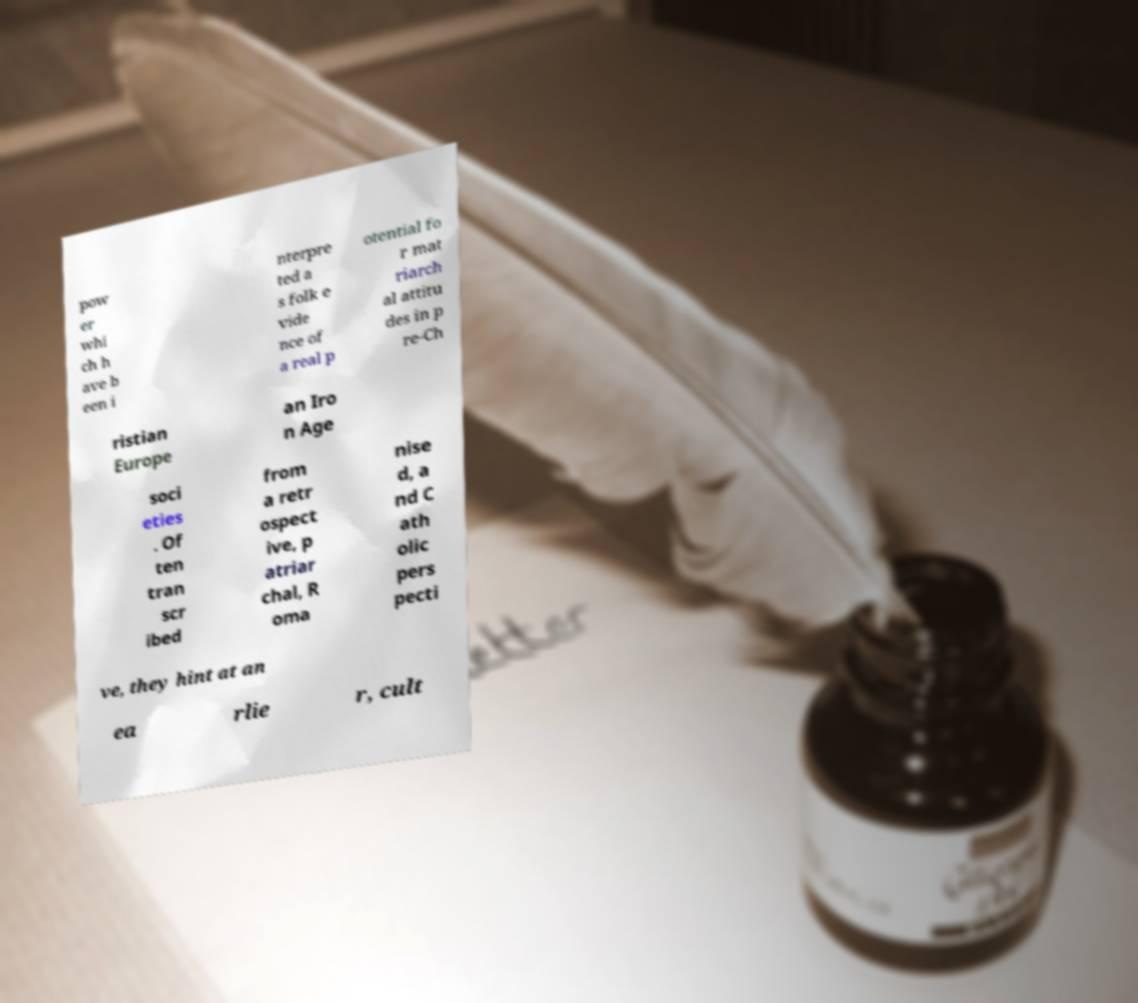Can you accurately transcribe the text from the provided image for me? pow er whi ch h ave b een i nterpre ted a s folk e vide nce of a real p otential fo r mat riarch al attitu des in p re-Ch ristian Europe an Iro n Age soci eties . Of ten tran scr ibed from a retr ospect ive, p atriar chal, R oma nise d, a nd C ath olic pers pecti ve, they hint at an ea rlie r, cult 